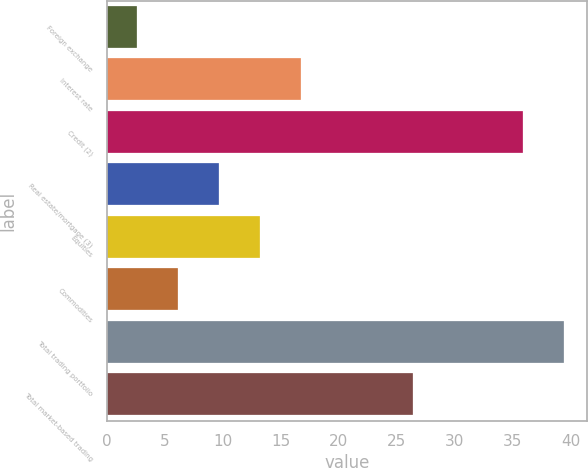<chart> <loc_0><loc_0><loc_500><loc_500><bar_chart><fcel>Foreign exchange<fcel>Interest rate<fcel>Credit (2)<fcel>Real estate/mortgage (3)<fcel>Equities<fcel>Commodities<fcel>Total trading portfolio<fcel>Total market-based trading<nl><fcel>2.6<fcel>16.76<fcel>35.9<fcel>9.68<fcel>13.22<fcel>6.14<fcel>39.44<fcel>26.4<nl></chart> 